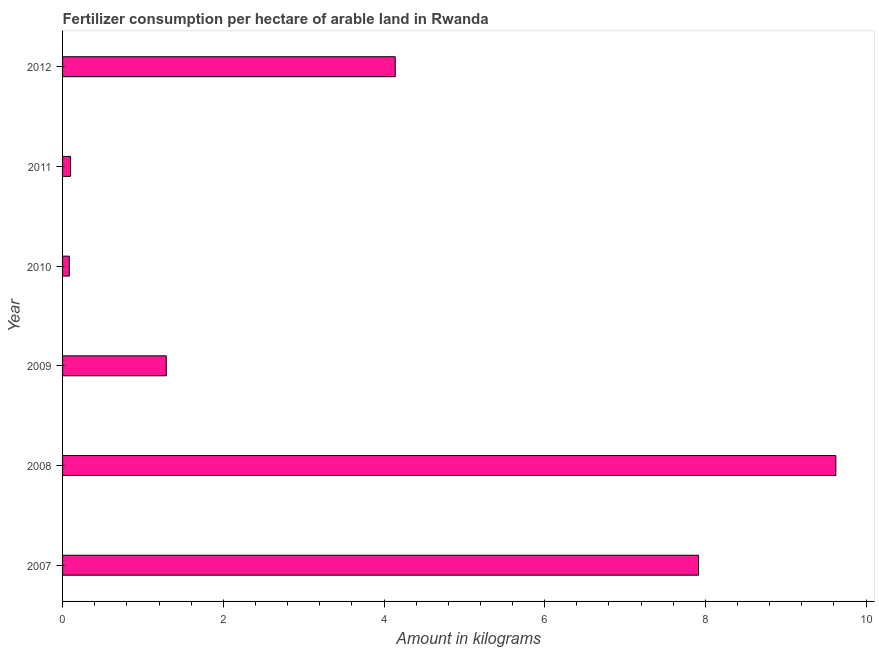Does the graph contain grids?
Your answer should be compact. No. What is the title of the graph?
Your answer should be compact. Fertilizer consumption per hectare of arable land in Rwanda . What is the label or title of the X-axis?
Provide a short and direct response. Amount in kilograms. What is the amount of fertilizer consumption in 2009?
Offer a terse response. 1.29. Across all years, what is the maximum amount of fertilizer consumption?
Offer a very short reply. 9.62. Across all years, what is the minimum amount of fertilizer consumption?
Keep it short and to the point. 0.08. In which year was the amount of fertilizer consumption maximum?
Your answer should be compact. 2008. In which year was the amount of fertilizer consumption minimum?
Ensure brevity in your answer.  2010. What is the sum of the amount of fertilizer consumption?
Your answer should be compact. 23.15. What is the difference between the amount of fertilizer consumption in 2007 and 2008?
Ensure brevity in your answer.  -1.71. What is the average amount of fertilizer consumption per year?
Provide a succinct answer. 3.86. What is the median amount of fertilizer consumption?
Make the answer very short. 2.72. Do a majority of the years between 2008 and 2007 (inclusive) have amount of fertilizer consumption greater than 6.8 kg?
Your response must be concise. No. What is the ratio of the amount of fertilizer consumption in 2007 to that in 2009?
Give a very brief answer. 6.13. Is the amount of fertilizer consumption in 2009 less than that in 2012?
Your answer should be very brief. Yes. What is the difference between the highest and the second highest amount of fertilizer consumption?
Keep it short and to the point. 1.71. What is the difference between the highest and the lowest amount of fertilizer consumption?
Your answer should be very brief. 9.54. Are all the bars in the graph horizontal?
Offer a terse response. Yes. How many years are there in the graph?
Offer a very short reply. 6. What is the difference between two consecutive major ticks on the X-axis?
Your answer should be compact. 2. What is the Amount in kilograms in 2007?
Your response must be concise. 7.91. What is the Amount in kilograms of 2008?
Offer a very short reply. 9.62. What is the Amount in kilograms in 2009?
Your response must be concise. 1.29. What is the Amount in kilograms of 2010?
Your response must be concise. 0.08. What is the Amount in kilograms in 2011?
Your answer should be compact. 0.1. What is the Amount in kilograms in 2012?
Your response must be concise. 4.14. What is the difference between the Amount in kilograms in 2007 and 2008?
Offer a terse response. -1.71. What is the difference between the Amount in kilograms in 2007 and 2009?
Offer a very short reply. 6.62. What is the difference between the Amount in kilograms in 2007 and 2010?
Your response must be concise. 7.83. What is the difference between the Amount in kilograms in 2007 and 2011?
Give a very brief answer. 7.81. What is the difference between the Amount in kilograms in 2007 and 2012?
Provide a short and direct response. 3.77. What is the difference between the Amount in kilograms in 2008 and 2009?
Your answer should be compact. 8.33. What is the difference between the Amount in kilograms in 2008 and 2010?
Give a very brief answer. 9.54. What is the difference between the Amount in kilograms in 2008 and 2011?
Make the answer very short. 9.52. What is the difference between the Amount in kilograms in 2008 and 2012?
Keep it short and to the point. 5.48. What is the difference between the Amount in kilograms in 2009 and 2010?
Your response must be concise. 1.21. What is the difference between the Amount in kilograms in 2009 and 2011?
Keep it short and to the point. 1.19. What is the difference between the Amount in kilograms in 2009 and 2012?
Give a very brief answer. -2.85. What is the difference between the Amount in kilograms in 2010 and 2011?
Your response must be concise. -0.02. What is the difference between the Amount in kilograms in 2010 and 2012?
Make the answer very short. -4.06. What is the difference between the Amount in kilograms in 2011 and 2012?
Make the answer very short. -4.04. What is the ratio of the Amount in kilograms in 2007 to that in 2008?
Your answer should be very brief. 0.82. What is the ratio of the Amount in kilograms in 2007 to that in 2009?
Give a very brief answer. 6.13. What is the ratio of the Amount in kilograms in 2007 to that in 2010?
Your response must be concise. 94.63. What is the ratio of the Amount in kilograms in 2007 to that in 2011?
Offer a very short reply. 79.25. What is the ratio of the Amount in kilograms in 2007 to that in 2012?
Your response must be concise. 1.91. What is the ratio of the Amount in kilograms in 2008 to that in 2009?
Offer a very short reply. 7.46. What is the ratio of the Amount in kilograms in 2008 to that in 2010?
Provide a succinct answer. 115.06. What is the ratio of the Amount in kilograms in 2008 to that in 2011?
Keep it short and to the point. 96.35. What is the ratio of the Amount in kilograms in 2008 to that in 2012?
Your answer should be compact. 2.32. What is the ratio of the Amount in kilograms in 2009 to that in 2010?
Your response must be concise. 15.43. What is the ratio of the Amount in kilograms in 2009 to that in 2011?
Give a very brief answer. 12.92. What is the ratio of the Amount in kilograms in 2009 to that in 2012?
Your response must be concise. 0.31. What is the ratio of the Amount in kilograms in 2010 to that in 2011?
Offer a very short reply. 0.84. What is the ratio of the Amount in kilograms in 2011 to that in 2012?
Keep it short and to the point. 0.02. 